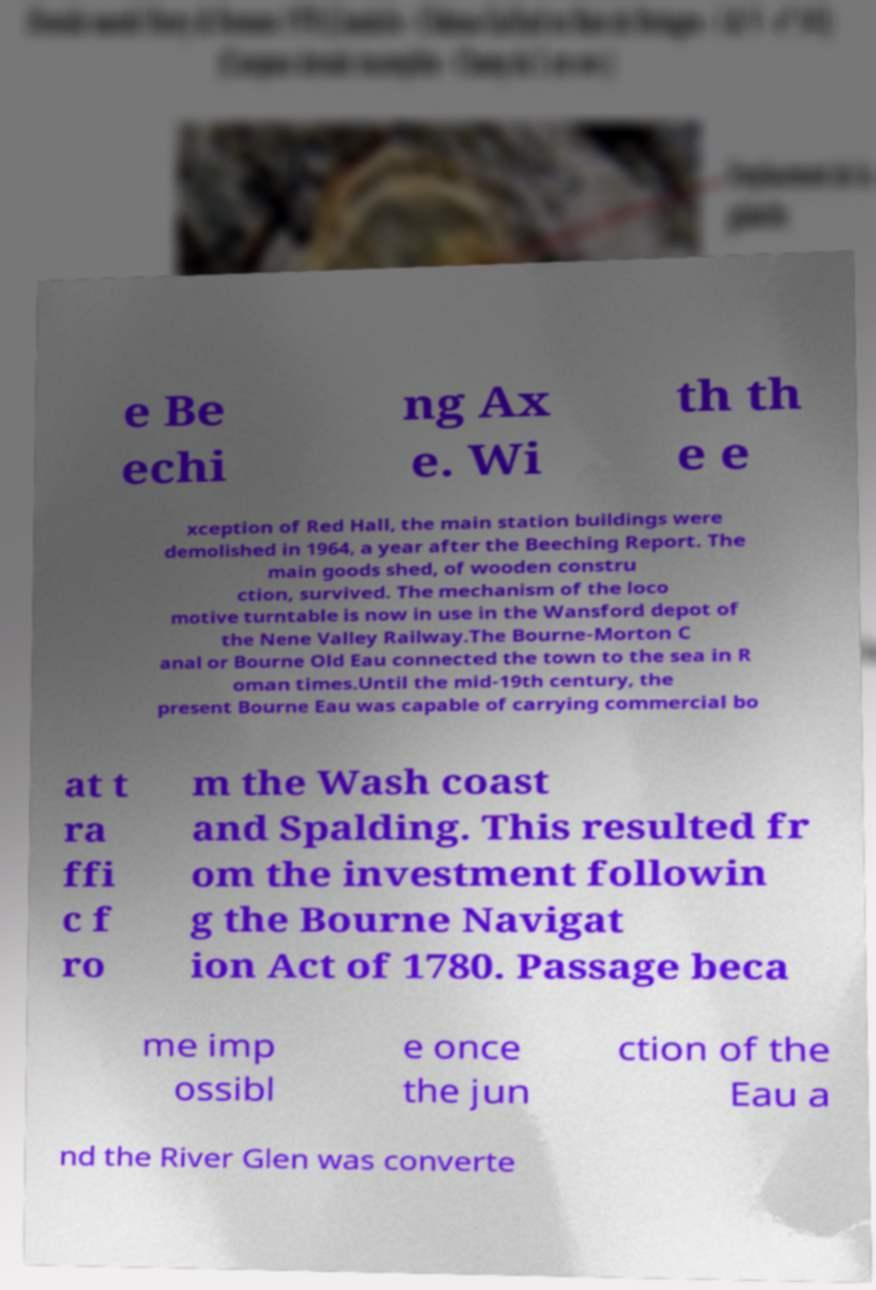What messages or text are displayed in this image? I need them in a readable, typed format. e Be echi ng Ax e. Wi th th e e xception of Red Hall, the main station buildings were demolished in 1964, a year after the Beeching Report. The main goods shed, of wooden constru ction, survived. The mechanism of the loco motive turntable is now in use in the Wansford depot of the Nene Valley Railway.The Bourne-Morton C anal or Bourne Old Eau connected the town to the sea in R oman times.Until the mid-19th century, the present Bourne Eau was capable of carrying commercial bo at t ra ffi c f ro m the Wash coast and Spalding. This resulted fr om the investment followin g the Bourne Navigat ion Act of 1780. Passage beca me imp ossibl e once the jun ction of the Eau a nd the River Glen was converte 